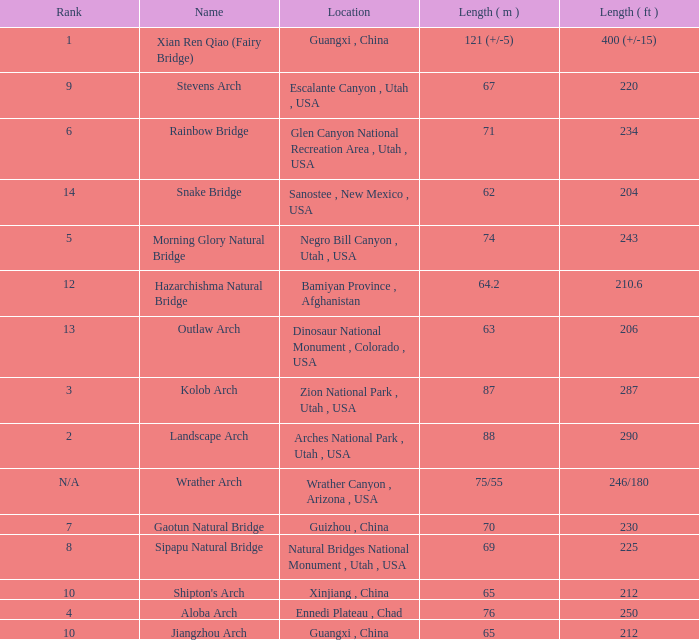What is the length in feet of the Jiangzhou arch? 212.0. 